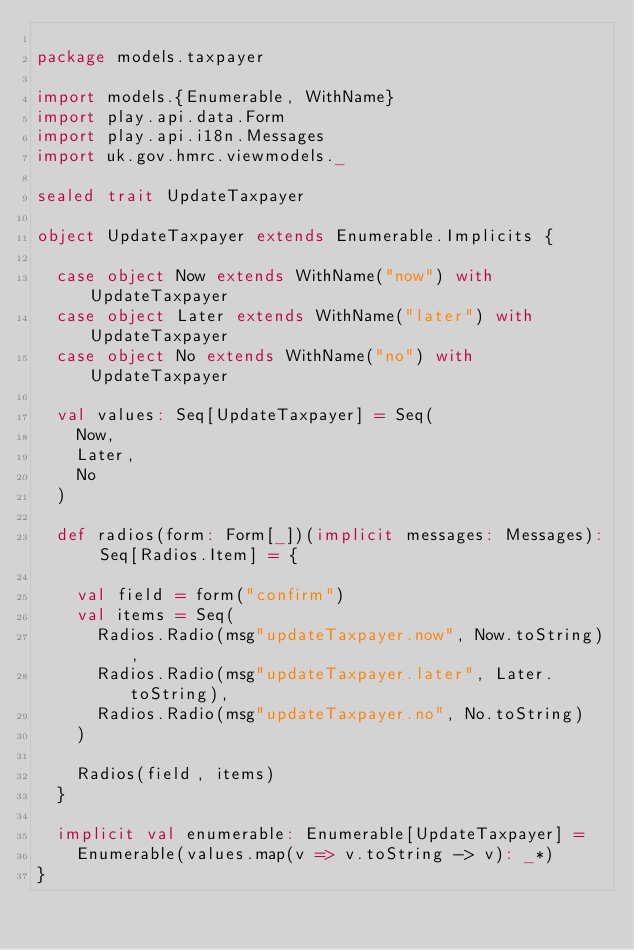<code> <loc_0><loc_0><loc_500><loc_500><_Scala_>
package models.taxpayer

import models.{Enumerable, WithName}
import play.api.data.Form
import play.api.i18n.Messages
import uk.gov.hmrc.viewmodels._

sealed trait UpdateTaxpayer

object UpdateTaxpayer extends Enumerable.Implicits {

  case object Now extends WithName("now") with UpdateTaxpayer
  case object Later extends WithName("later") with UpdateTaxpayer
  case object No extends WithName("no") with UpdateTaxpayer

  val values: Seq[UpdateTaxpayer] = Seq(
    Now,
    Later,
    No
  )

  def radios(form: Form[_])(implicit messages: Messages): Seq[Radios.Item] = {

    val field = form("confirm")
    val items = Seq(
      Radios.Radio(msg"updateTaxpayer.now", Now.toString),
      Radios.Radio(msg"updateTaxpayer.later", Later.toString),
      Radios.Radio(msg"updateTaxpayer.no", No.toString)
    )

    Radios(field, items)
  }

  implicit val enumerable: Enumerable[UpdateTaxpayer] =
    Enumerable(values.map(v => v.toString -> v): _*)
}
</code> 